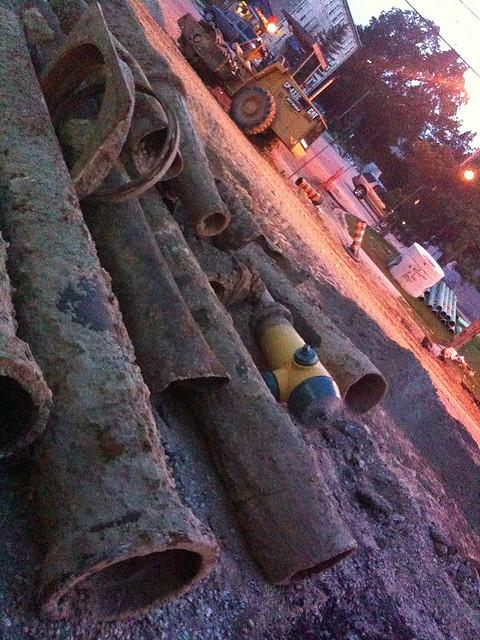What type of site is this? construction 